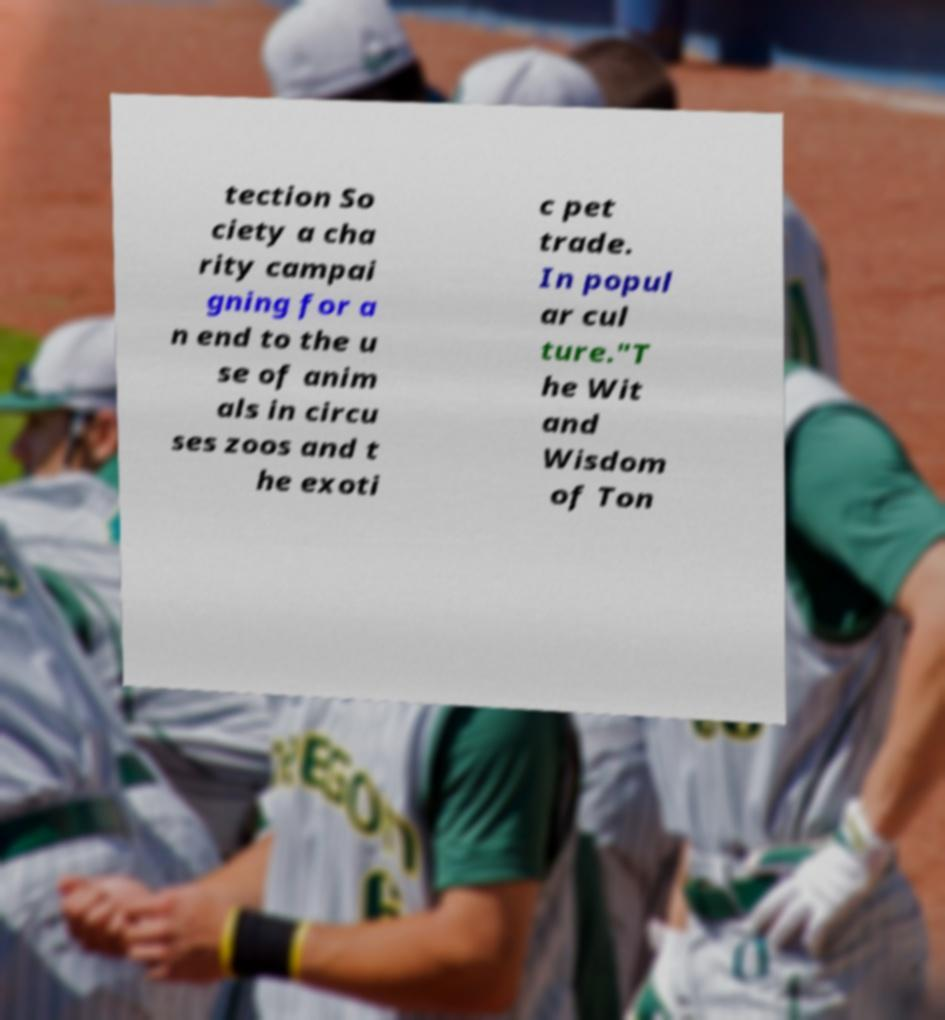Could you extract and type out the text from this image? tection So ciety a cha rity campai gning for a n end to the u se of anim als in circu ses zoos and t he exoti c pet trade. In popul ar cul ture."T he Wit and Wisdom of Ton 